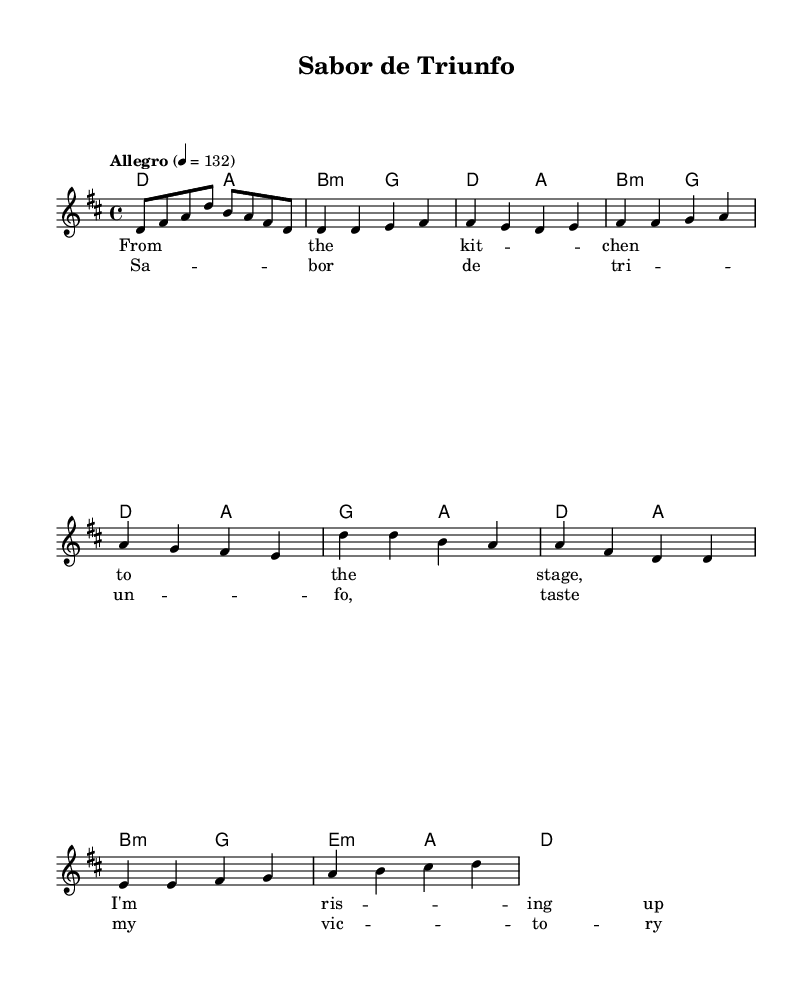What is the key signature of this music? The key signature is D major, which has two sharps: F# and C#. This can be determined by looking at the key indicated at the beginning of the score.
Answer: D major What is the time signature of this piece? The time signature is 4/4, which is indicated at the beginning of the score. It means there are four beats in each measure and the quarter note gets one beat.
Answer: 4/4 What is the tempo marking for this piece? The tempo marking is "Allegro," which indicates a lively and fast tempo. The numeric value 132 indicates the speed of 132 beats per minute.
Answer: Allegro How many measures are in the chorus section? The chorus consists of four measures, which can be observed by counting the measures in the designated chorus section of the score.
Answer: Four What chord is played in the second measure of the verse? The chord played in the second measure of the verse is A major, as indicated by the chord names in the score under the respective measures.
Answer: A major Which section contains the lyric "Sabor de triunfo"? The lyric "Sabor de triunfo" is found in the chorus section, as indicated by the layout of the score where the chorus lyrics are written.
Answer: Chorus What is the last chord in the piece? The last chord in the piece is D major, as indicated by the chord symbols and the final measure which concludes with this chord.
Answer: D major 